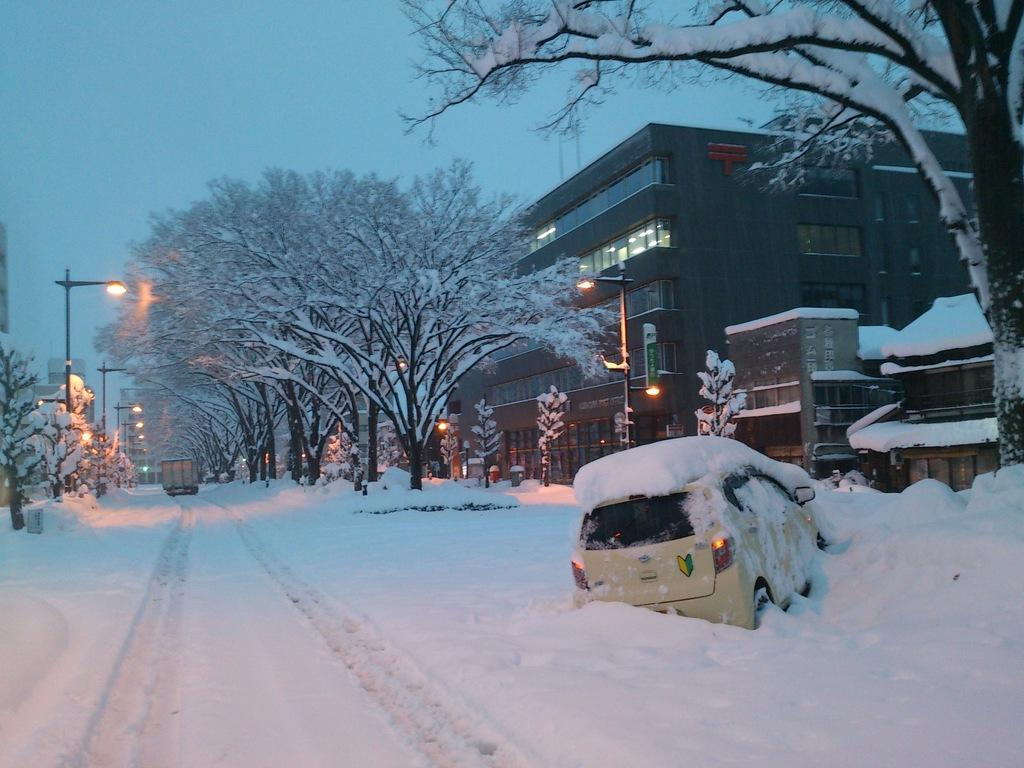What types of objects can be seen in the image? There are vehicles, trees, poles, lights, and buildings in the image. What is the weather like in the image? There is snow visible in the image, indicating a cold or wintery environment. What can be seen in the background of the image? The sky is visible in the background of the image. What level of metal is present in the image? There is no mention of metal or any specific level in the image. What act is being performed by the vehicles in the image? The vehicles are not performing any act; they are stationary objects in the image. 